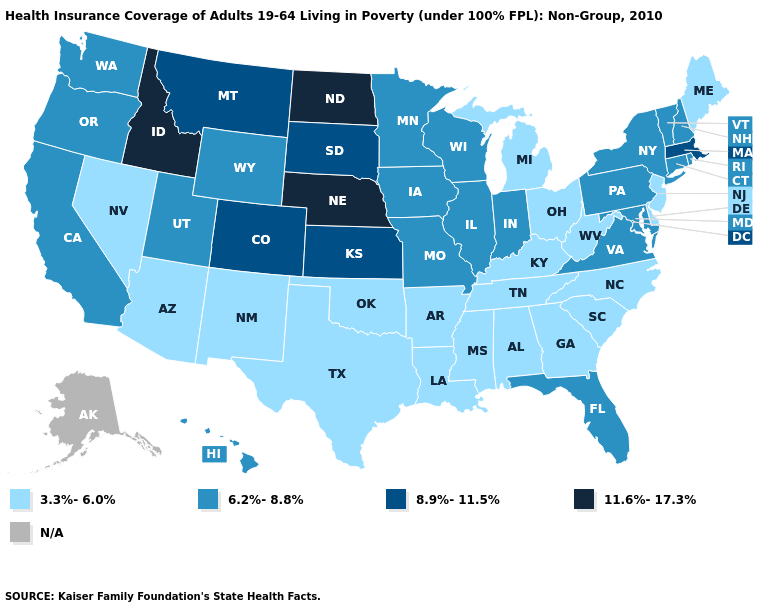Name the states that have a value in the range 8.9%-11.5%?
Write a very short answer. Colorado, Kansas, Massachusetts, Montana, South Dakota. Which states hav the highest value in the Northeast?
Be succinct. Massachusetts. Among the states that border Oregon , which have the lowest value?
Keep it brief. Nevada. Name the states that have a value in the range 11.6%-17.3%?
Keep it brief. Idaho, Nebraska, North Dakota. Among the states that border Oregon , does Nevada have the highest value?
Write a very short answer. No. Does Michigan have the highest value in the USA?
Give a very brief answer. No. Does Rhode Island have the highest value in the USA?
Give a very brief answer. No. Name the states that have a value in the range 8.9%-11.5%?
Short answer required. Colorado, Kansas, Massachusetts, Montana, South Dakota. Name the states that have a value in the range 11.6%-17.3%?
Quick response, please. Idaho, Nebraska, North Dakota. What is the value of Pennsylvania?
Quick response, please. 6.2%-8.8%. Which states hav the highest value in the Northeast?
Short answer required. Massachusetts. Which states have the lowest value in the USA?
Answer briefly. Alabama, Arizona, Arkansas, Delaware, Georgia, Kentucky, Louisiana, Maine, Michigan, Mississippi, Nevada, New Jersey, New Mexico, North Carolina, Ohio, Oklahoma, South Carolina, Tennessee, Texas, West Virginia. Among the states that border Pennsylvania , which have the lowest value?
Write a very short answer. Delaware, New Jersey, Ohio, West Virginia. What is the lowest value in states that border North Dakota?
Answer briefly. 6.2%-8.8%. 